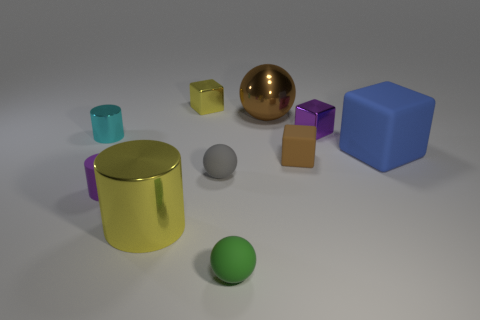How many things are tiny spheres that are behind the rubber cylinder or yellow metallic things behind the brown rubber thing?
Offer a terse response. 2. Are there an equal number of purple matte cylinders behind the blue cube and small balls that are in front of the small yellow thing?
Keep it short and to the point. No. What is the color of the big metallic object in front of the purple matte cylinder?
Give a very brief answer. Yellow. Is the color of the metal ball the same as the large metal thing that is in front of the blue object?
Your response must be concise. No. Is the number of big gray rubber balls less than the number of gray spheres?
Offer a very short reply. Yes. Does the block in front of the blue object have the same color as the shiny ball?
Offer a very short reply. Yes. What number of other brown cubes have the same size as the brown block?
Offer a very short reply. 0. Is there a large shiny sphere that has the same color as the small matte cylinder?
Ensure brevity in your answer.  No. Do the large block and the tiny yellow object have the same material?
Keep it short and to the point. No. How many yellow metallic things have the same shape as the cyan metal thing?
Make the answer very short. 1. 